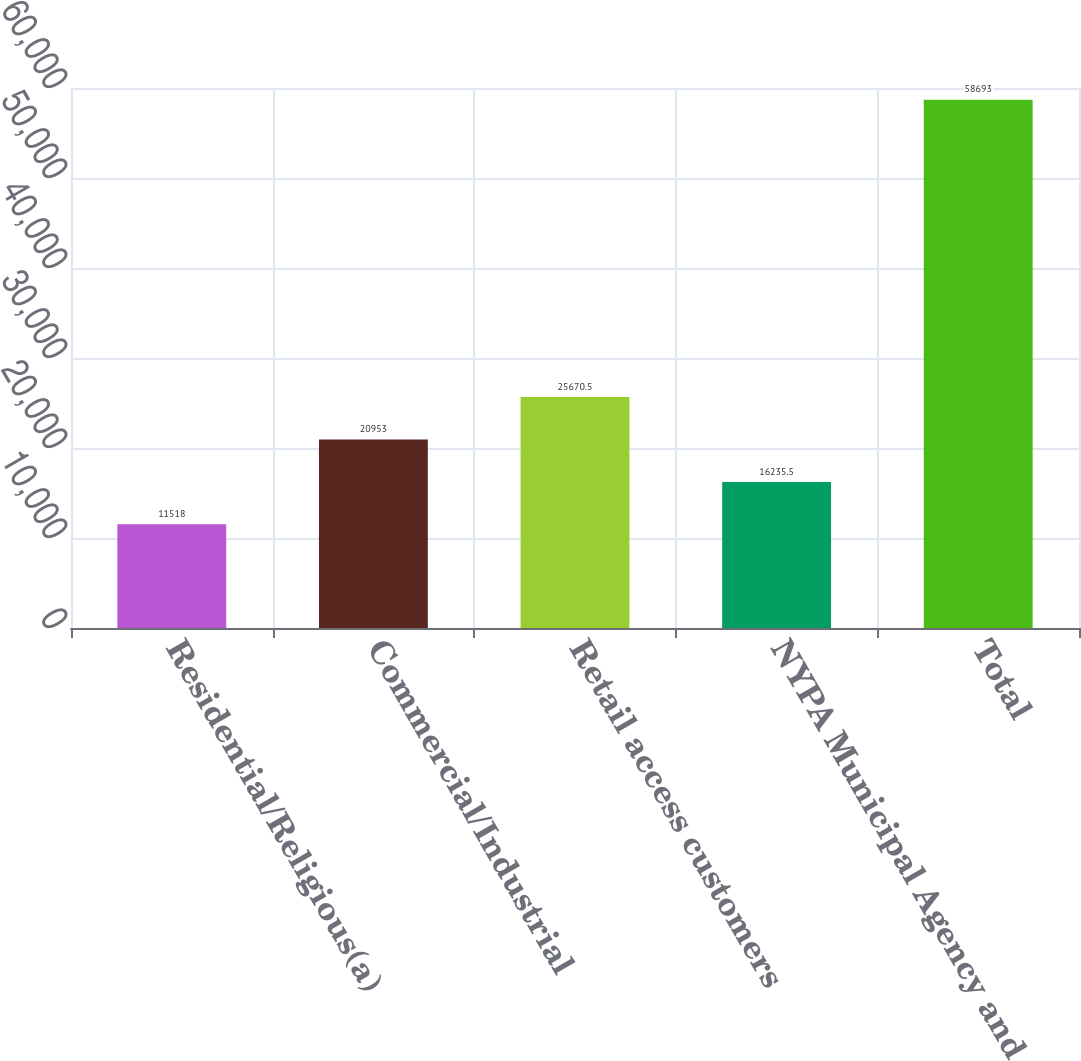<chart> <loc_0><loc_0><loc_500><loc_500><bar_chart><fcel>Residential/Religious(a)<fcel>Commercial/Industrial<fcel>Retail access customers<fcel>NYPA Municipal Agency and<fcel>Total<nl><fcel>11518<fcel>20953<fcel>25670.5<fcel>16235.5<fcel>58693<nl></chart> 